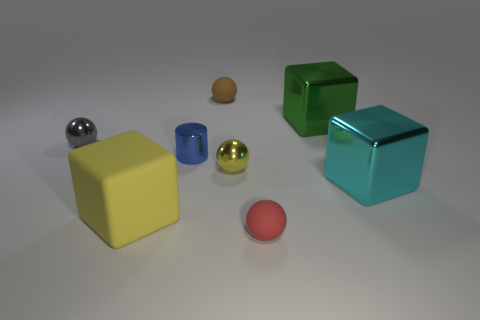What material do the objects in the image seem to be made of? The objects in the image exhibit various textures that suggest they're made of different materials. The yellow and cyan objects appear to have a matte plastic finish, while the green object looks to have a reflective metallic surface. The silver and golden spheres suggest a polished metallic composition, and the smaller objects—brown and the red sphere—seem to be made of clay or a material with a similar matte finish. 